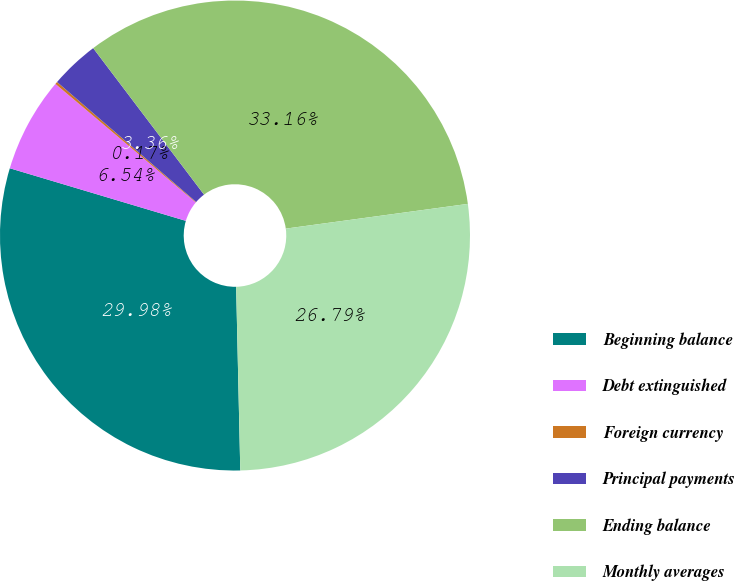Convert chart to OTSL. <chart><loc_0><loc_0><loc_500><loc_500><pie_chart><fcel>Beginning balance<fcel>Debt extinguished<fcel>Foreign currency<fcel>Principal payments<fcel>Ending balance<fcel>Monthly averages<nl><fcel>29.98%<fcel>6.54%<fcel>0.17%<fcel>3.36%<fcel>33.16%<fcel>26.79%<nl></chart> 